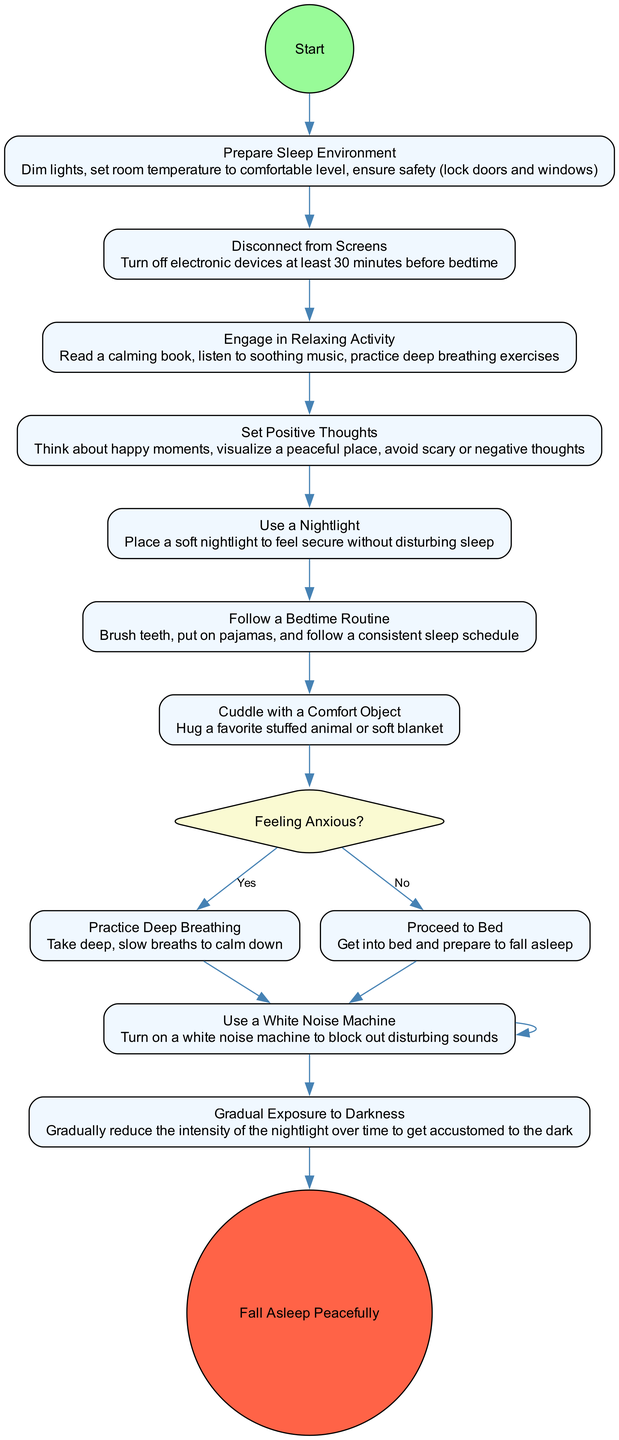what's the first action in the diagram? The first action listed in the diagram is "Prepare Sleep Environment," which appears directly after the start node.
Answer: Prepare Sleep Environment how many actions are there in the activity diagram? By counting the number of elements labeled as actions, there are six actions leading to the end of the process.
Answer: 6 what decision point is present in the diagram? The decision point present in the diagram is "Feeling Anxious?" which determines the next steps based on the user's feelings.
Answer: Feeling Anxious? what happens if the answer to the decision "Feeling Anxious?" is "Yes"? If the answer is "Yes," the next action is "Practice Deep Breathing," which helps calm the user down before proceeding.
Answer: Practice Deep Breathing which action follows "Cuddle with a Comfort Object"? The next action after "Cuddle with a Comfort Object" is the decision "Feeling Anxious?" indicating the user's feelings must be assessed next.
Answer: Feeling Anxious? what is the last action before falling asleep? The last action before "Fall Asleep Peacefully" is "Use a White Noise Machine," which is implemented to create a calming environment.
Answer: Use a White Noise Machine how does "Use a Nightlight" relate to the process? "Use a Nightlight" is an action that provides a comforting light source meant to help the participant feel secure while preparing for sleep.
Answer: Provides security what signifies the end of the process in the diagram? The end of the process is represented by the node labeled "Fall Asleep Peacefully," indicating the successful completion of steps to achieve a peaceful sleep.
Answer: Fall Asleep Peacefully 